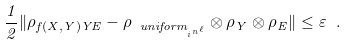Convert formula to latex. <formula><loc_0><loc_0><loc_500><loc_500>\frac { 1 } { 2 } \| \rho _ { f ( X , Y ) Y E } - \rho _ { \ u n i f o r m _ { _ { i } n ^ { \ell } } } \otimes \rho _ { Y } \otimes \rho _ { E } \| \leq \varepsilon \ .</formula> 